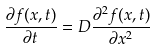Convert formula to latex. <formula><loc_0><loc_0><loc_500><loc_500>\frac { \partial f ( x , t ) } { \partial t } = D \frac { \partial ^ { 2 } f ( x , t ) } { \partial x ^ { 2 } }</formula> 